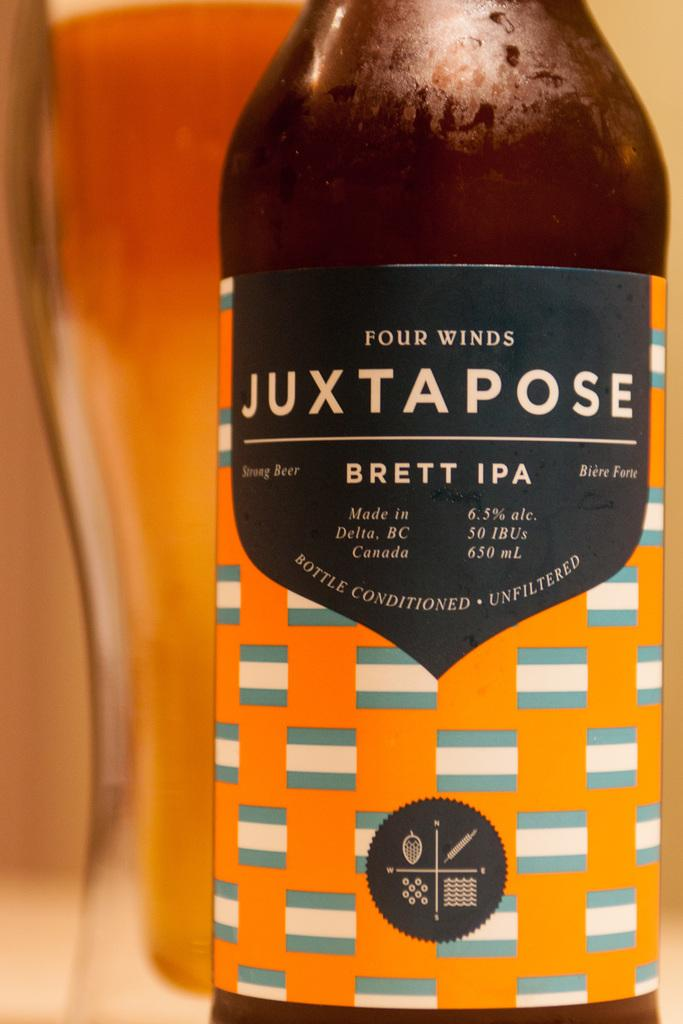<image>
Summarize the visual content of the image. A bottle of Four Winds Juxtapose has an orange label. 